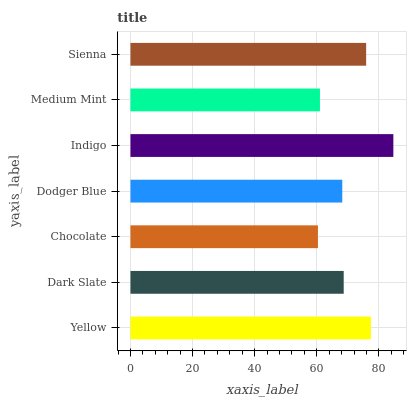Is Chocolate the minimum?
Answer yes or no. Yes. Is Indigo the maximum?
Answer yes or no. Yes. Is Dark Slate the minimum?
Answer yes or no. No. Is Dark Slate the maximum?
Answer yes or no. No. Is Yellow greater than Dark Slate?
Answer yes or no. Yes. Is Dark Slate less than Yellow?
Answer yes or no. Yes. Is Dark Slate greater than Yellow?
Answer yes or no. No. Is Yellow less than Dark Slate?
Answer yes or no. No. Is Dark Slate the high median?
Answer yes or no. Yes. Is Dark Slate the low median?
Answer yes or no. Yes. Is Indigo the high median?
Answer yes or no. No. Is Dodger Blue the low median?
Answer yes or no. No. 